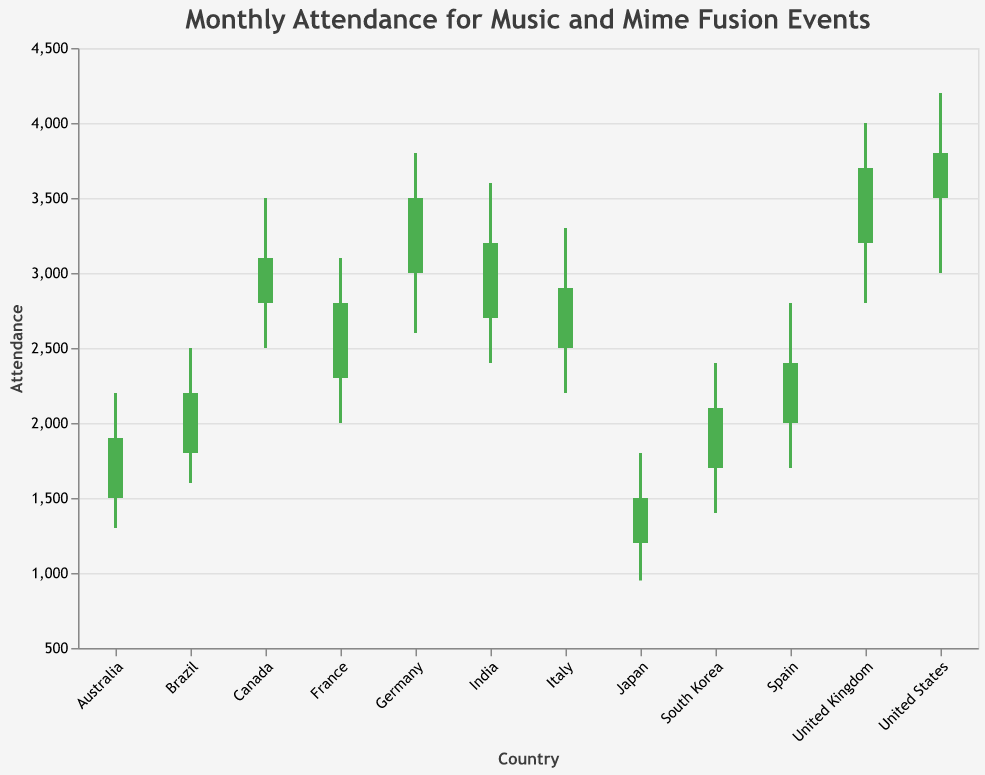How many countries have their closing attendance numbers higher than the opening attendance numbers? There are 12 countries represented in the chart. By inspecting each country's opening and closing attendance numbers, we see that Japan, France, Brazil, United States, India, Germany, Spain, Canada, United Kingdom, and South Korea have higher closing numbers than opening.
Answer: 10 Which country had the highest peak attendance for music and mime fusion events? Looking at the "High" values for each country, we observe that the United States had the highest peak attendance of 4200.
Answer: United States What was the lowest recorded attendance in Japan for January? By checking the "Low" values for Japan in January, it is clear that the lowest recorded attendance was 950.
Answer: 950 Which months showed a decrease in attendance from opening to closing for their respective countries? By comparing the opening and closing attendance numbers, we see that in Japan, Australia, and Italy the closing attendance was lower than the opening attendance.
Answer: January, July, October Compare the closing attendance of United Kingdom and Germany. Which is higher? The closing attendance for the United Kingdom in November is 3700 and for Germany in June is 3500. Therefore, the United Kingdom has a higher closing attendance.
Answer: United Kingdom What is the range in attendance for events in Brazil in March? The range is calculated by subtracting the lowest attendance from the highest attendance for Brazil in March. High is 2500 and Low is 1600. The range is 2500 - 1600 = 900.
Answer: 900 How many countries have a minimum attendance below 1500? By checking the "Low" values for each country, we see that Japan (950), Australia (1300), and South Korea (1400) have minimum attendance figures below 1500.
Answer: 3 What is the average closing attendance across all countries? To find the average, sum all the closing attendance numbers and divide by the number of countries. The closing attendances are: 1500, 2800, 2200, 3800, 3200, 3500, 1900, 2400, 3100, 2900, 3700, 2100, totaling 33300. Divide that by 12 (number of countries): 33300/12 = 2775.
Answer: 2775 Which country had the narrowest range between high and low attendance? The range is calculated by subtracting the "Low" value from the "High" value for each country. Australia had a High of 2200 and a Low of 1300, resulting in a range of 900, which is the narrowest range among all the countries.
Answer: Australia 